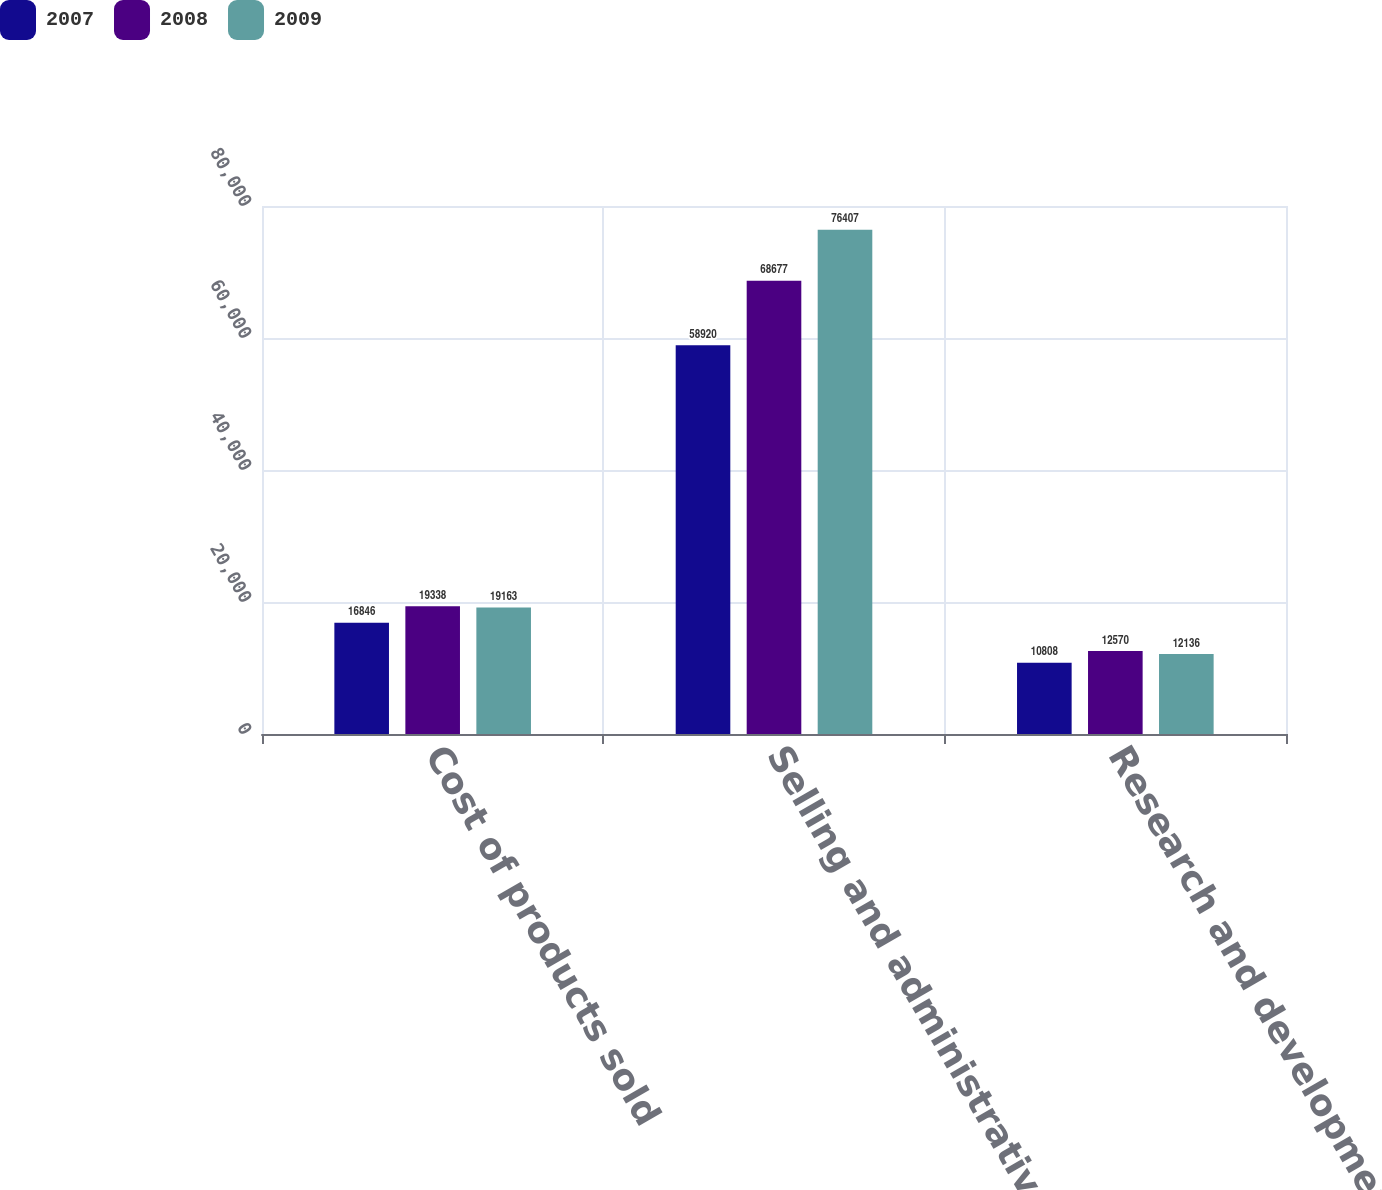Convert chart. <chart><loc_0><loc_0><loc_500><loc_500><stacked_bar_chart><ecel><fcel>Cost of products sold<fcel>Selling and administrative<fcel>Research and development<nl><fcel>2007<fcel>16846<fcel>58920<fcel>10808<nl><fcel>2008<fcel>19338<fcel>68677<fcel>12570<nl><fcel>2009<fcel>19163<fcel>76407<fcel>12136<nl></chart> 